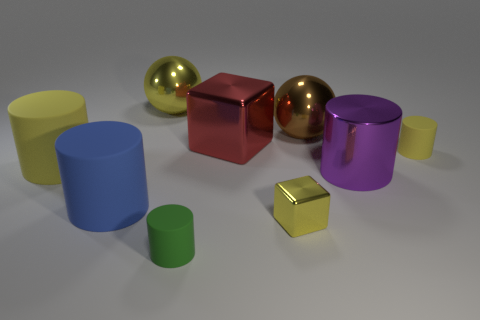Is there another blue rubber thing of the same shape as the large blue thing?
Make the answer very short. No. Is the number of small yellow cylinders that are to the left of the big metal block less than the number of tiny cyan cubes?
Ensure brevity in your answer.  No. Does the big blue object have the same shape as the small green object?
Your answer should be very brief. Yes. There is a yellow metallic thing in front of the large blue rubber cylinder; what size is it?
Offer a very short reply. Small. The blue thing that is made of the same material as the big yellow cylinder is what size?
Keep it short and to the point. Large. Is the number of brown shiny things less than the number of big brown matte cylinders?
Your answer should be very brief. No. What material is the yellow cylinder that is the same size as the purple object?
Provide a succinct answer. Rubber. Is the number of large rubber things greater than the number of large purple shiny objects?
Provide a short and direct response. Yes. What number of other objects are the same color as the large metallic cylinder?
Offer a very short reply. 0. What number of small cylinders are both behind the tiny green cylinder and in front of the purple metallic object?
Offer a terse response. 0. 